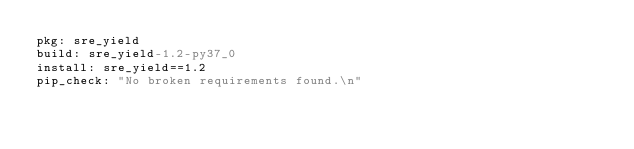Convert code to text. <code><loc_0><loc_0><loc_500><loc_500><_YAML_>pkg: sre_yield
build: sre_yield-1.2-py37_0
install: sre_yield==1.2
pip_check: "No broken requirements found.\n"
</code> 